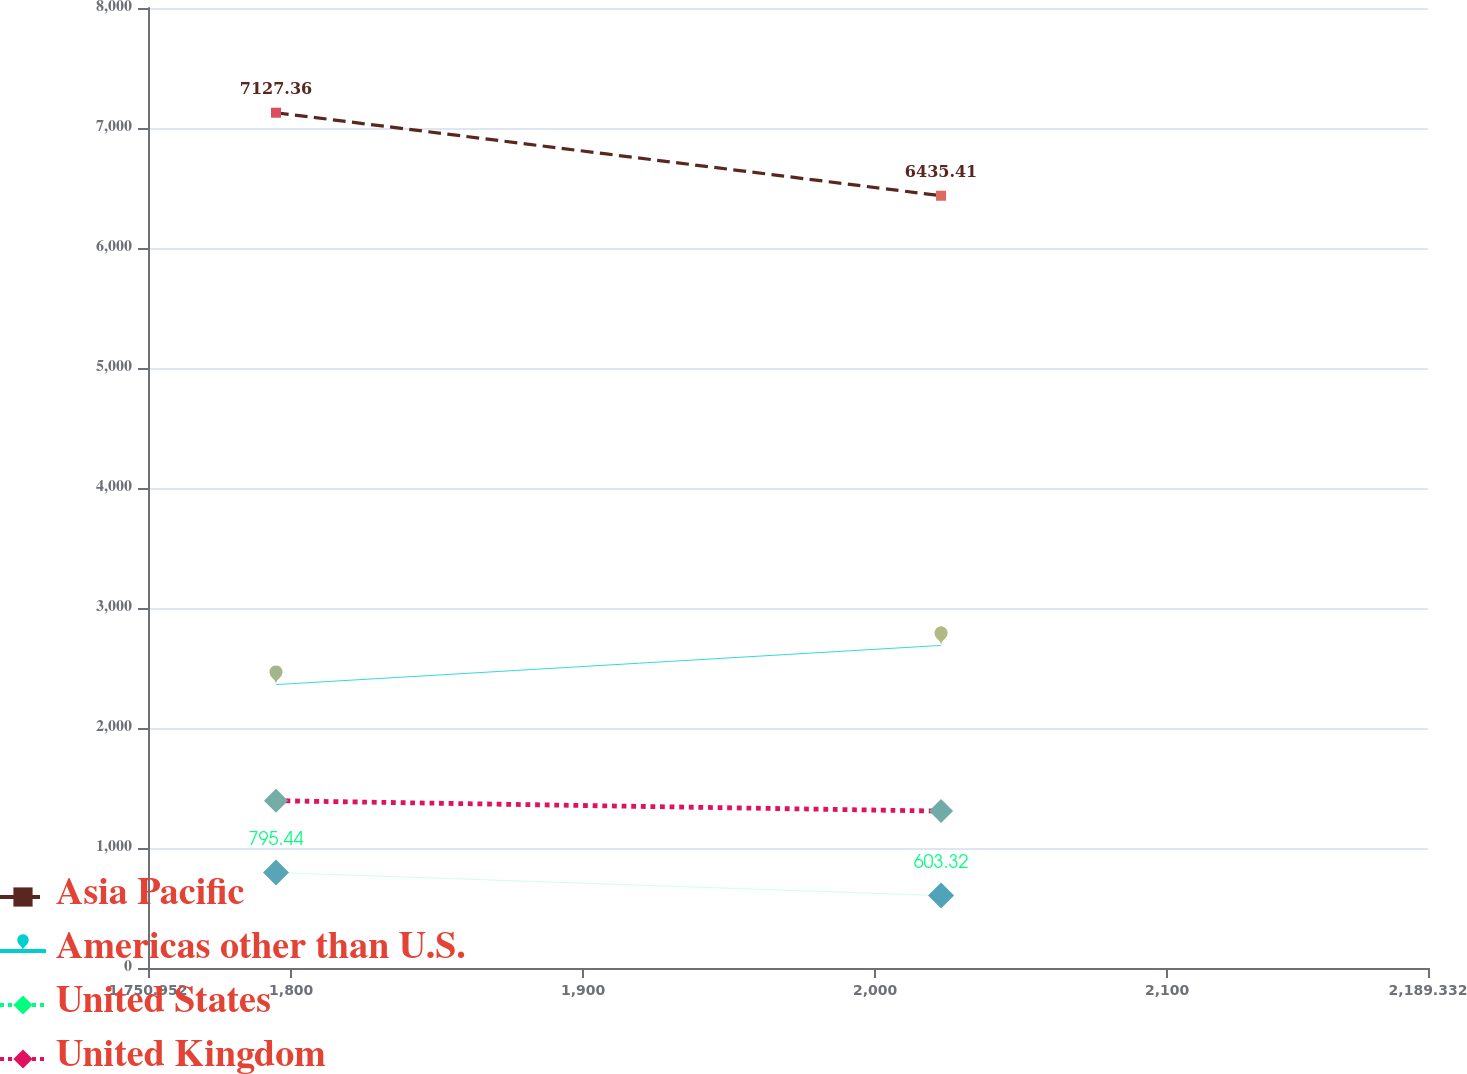<chart> <loc_0><loc_0><loc_500><loc_500><line_chart><ecel><fcel>Asia Pacific<fcel>Americas other than U.S.<fcel>United States<fcel>United Kingdom<nl><fcel>1794.79<fcel>7127.36<fcel>2361.83<fcel>795.44<fcel>1394.06<nl><fcel>2022.56<fcel>6435.41<fcel>2688.15<fcel>603.32<fcel>1307.54<nl><fcel>2233.17<fcel>5783.86<fcel>2532.77<fcel>680.58<fcel>983.47<nl></chart> 